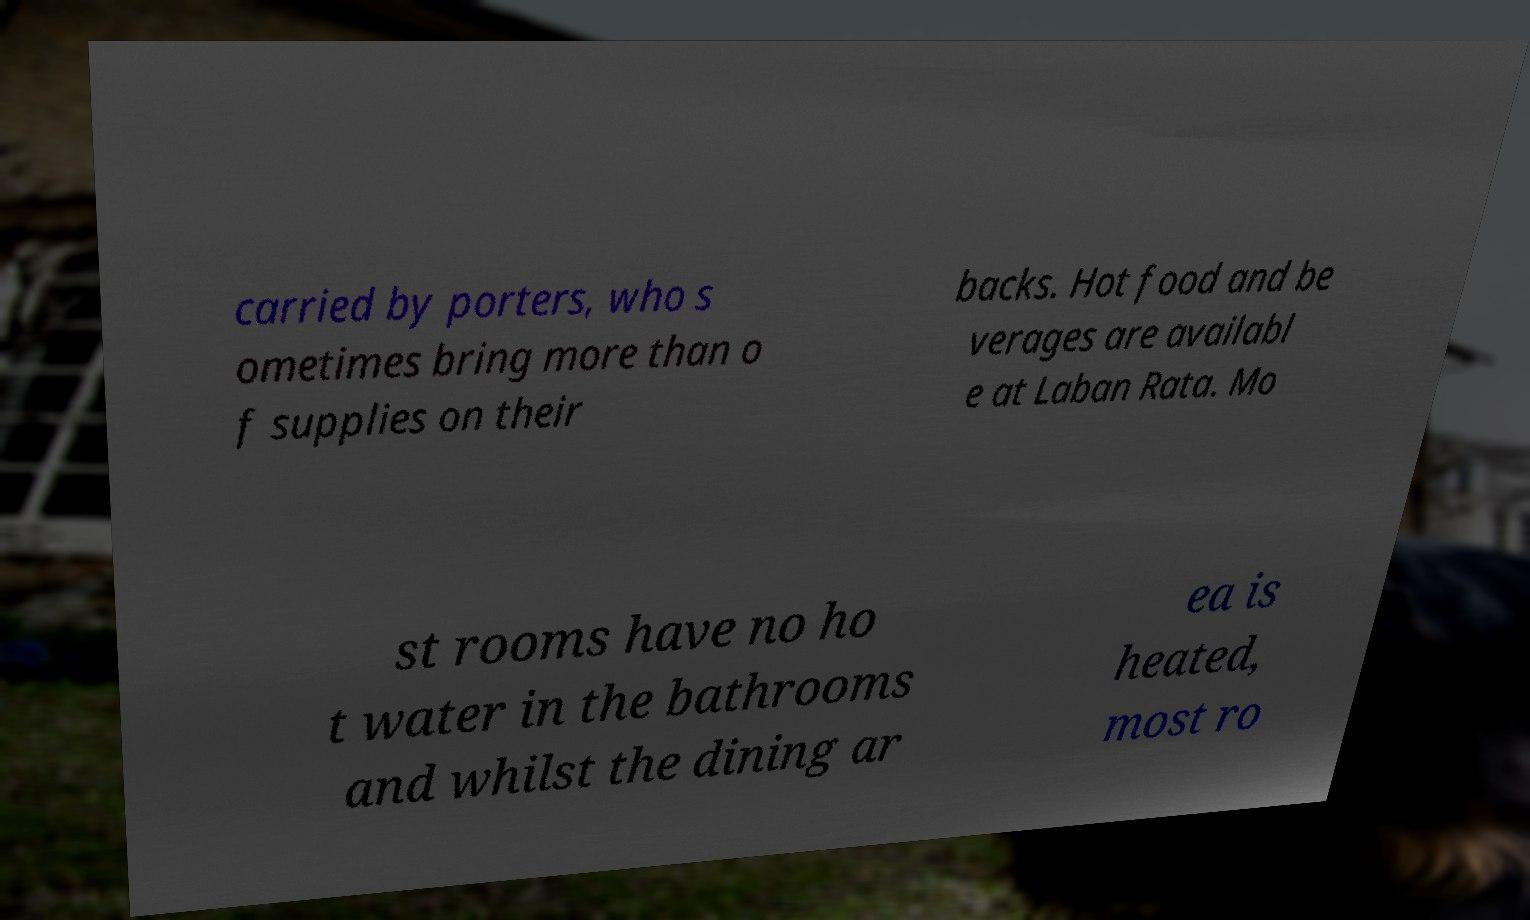Could you assist in decoding the text presented in this image and type it out clearly? carried by porters, who s ometimes bring more than o f supplies on their backs. Hot food and be verages are availabl e at Laban Rata. Mo st rooms have no ho t water in the bathrooms and whilst the dining ar ea is heated, most ro 